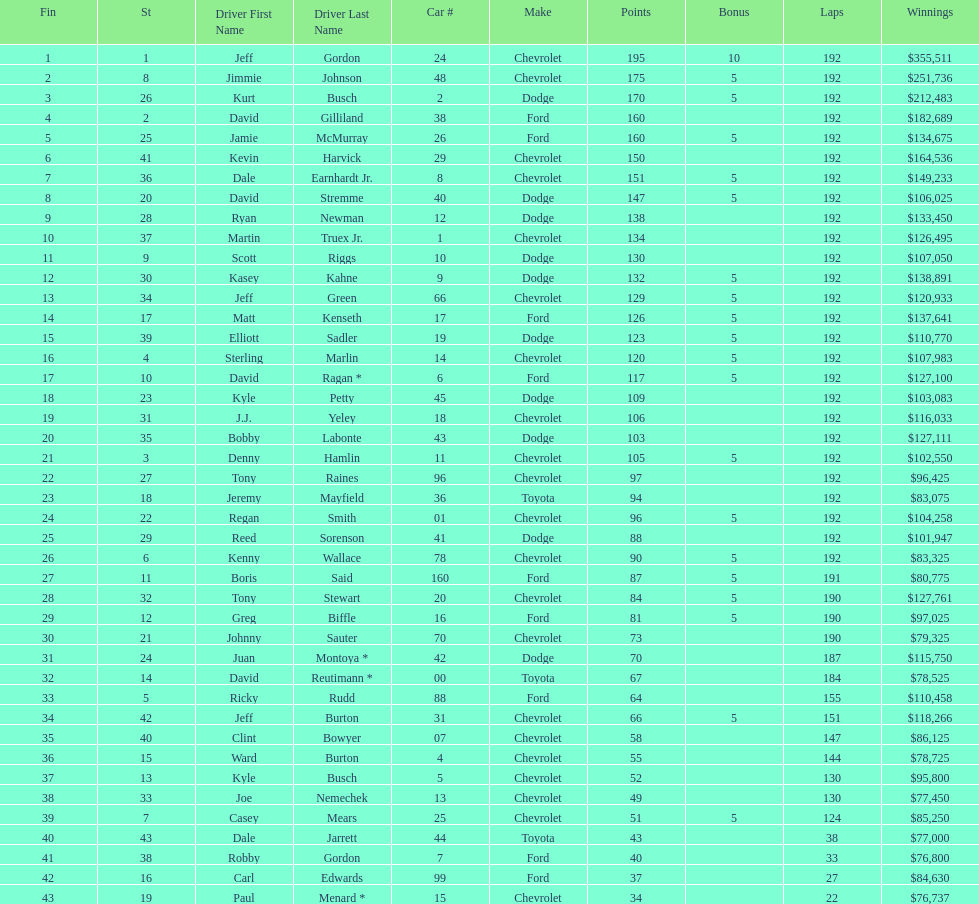How many drivers earned no bonus for this race? 23. 